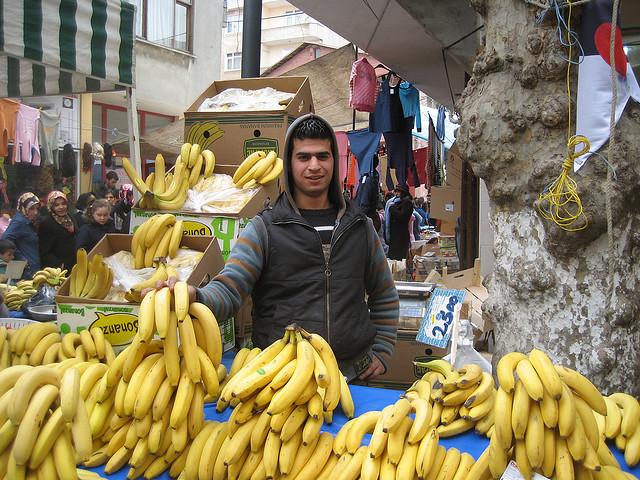Is the man wearing a jacket?
Concise answer only. Yes. Does the man like bananas?
Be succinct. Yes. How many bananas are in this picture?
Keep it brief. 100. 